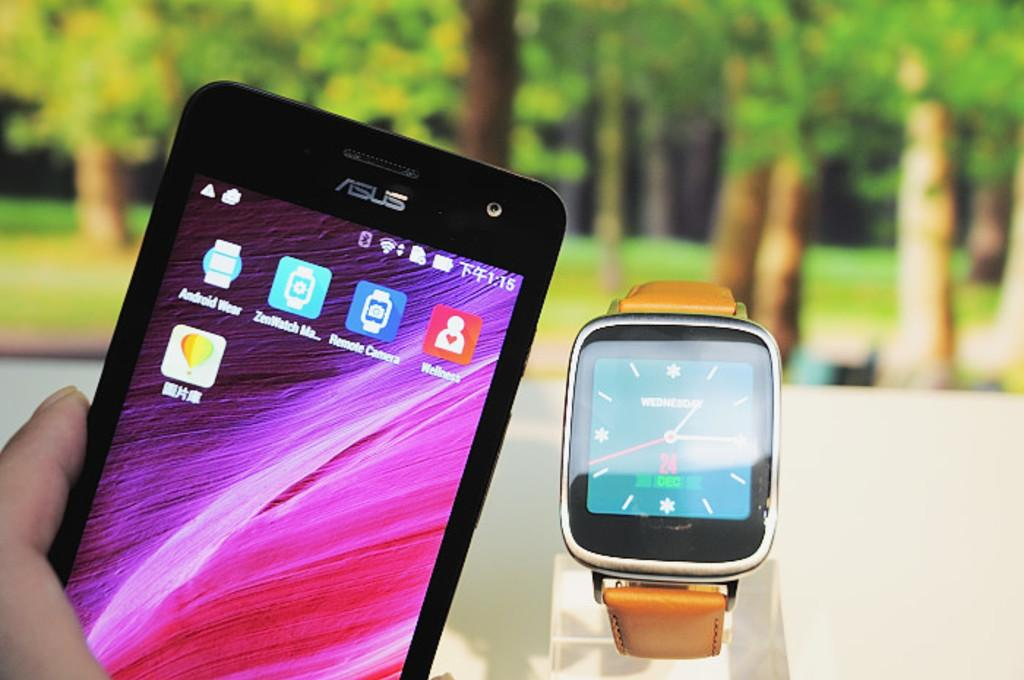<image>
Present a compact description of the photo's key features. Person holding a cellphone next to a watch that has a number 24 on it. 